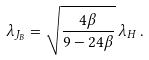Convert formula to latex. <formula><loc_0><loc_0><loc_500><loc_500>\lambda _ { J _ { B } } = \sqrt { \frac { 4 \beta } { 9 - 2 4 \beta } } \, \lambda _ { H } \, .</formula> 